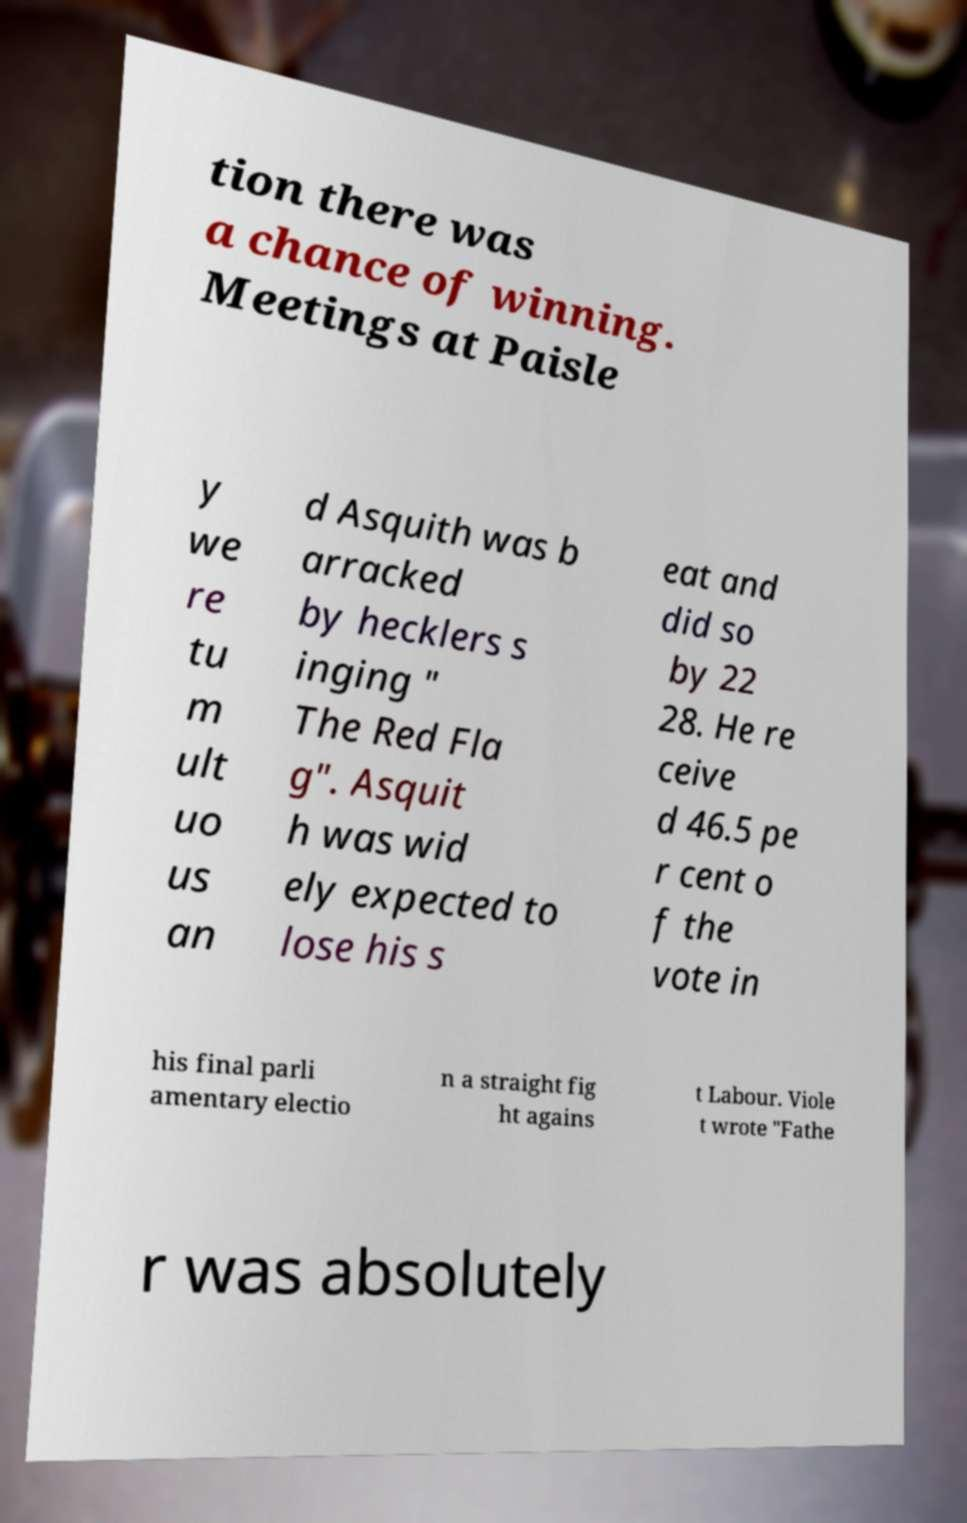Can you accurately transcribe the text from the provided image for me? tion there was a chance of winning. Meetings at Paisle y we re tu m ult uo us an d Asquith was b arracked by hecklers s inging " The Red Fla g". Asquit h was wid ely expected to lose his s eat and did so by 22 28. He re ceive d 46.5 pe r cent o f the vote in his final parli amentary electio n a straight fig ht agains t Labour. Viole t wrote "Fathe r was absolutely 